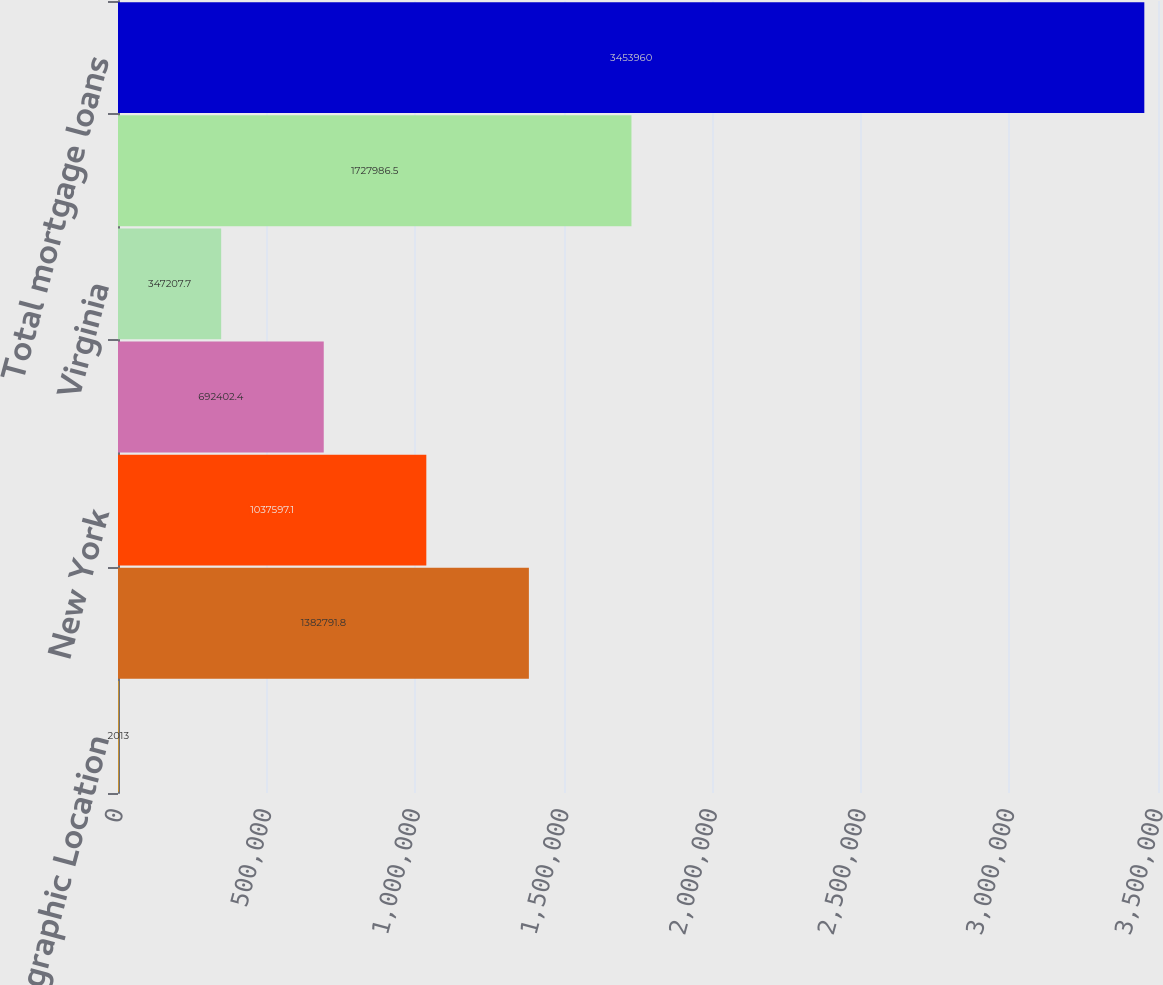<chart> <loc_0><loc_0><loc_500><loc_500><bar_chart><fcel>Geographic Location<fcel>California<fcel>New York<fcel>Florida<fcel>Virginia<fcel>Other states<fcel>Total mortgage loans<nl><fcel>2013<fcel>1.38279e+06<fcel>1.0376e+06<fcel>692402<fcel>347208<fcel>1.72799e+06<fcel>3.45396e+06<nl></chart> 